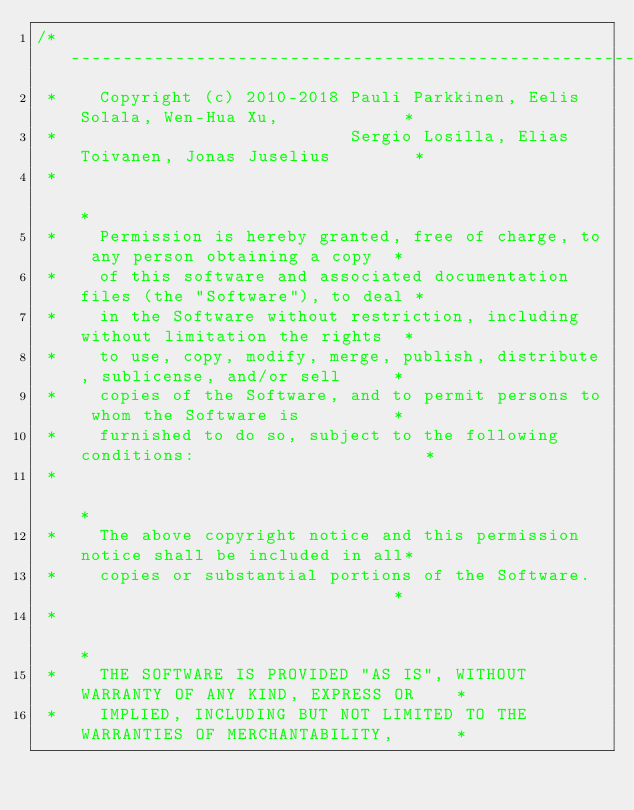Convert code to text. <code><loc_0><loc_0><loc_500><loc_500><_Cuda_>/*----------------------------------------------------------------------------------*
 *    Copyright (c) 2010-2018 Pauli Parkkinen, Eelis Solala, Wen-Hua Xu,            *
 *                            Sergio Losilla, Elias Toivanen, Jonas Juselius        *
 *                                                                                  *
 *    Permission is hereby granted, free of charge, to any person obtaining a copy  *
 *    of this software and associated documentation files (the "Software"), to deal *
 *    in the Software without restriction, including without limitation the rights  *
 *    to use, copy, modify, merge, publish, distribute, sublicense, and/or sell     *
 *    copies of the Software, and to permit persons to whom the Software is         *
 *    furnished to do so, subject to the following conditions:                      *
 *                                                                                  *
 *    The above copyright notice and this permission notice shall be included in all*
 *    copies or substantial portions of the Software.                               *
 *                                                                                  *
 *    THE SOFTWARE IS PROVIDED "AS IS", WITHOUT WARRANTY OF ANY KIND, EXPRESS OR    *
 *    IMPLIED, INCLUDING BUT NOT LIMITED TO THE WARRANTIES OF MERCHANTABILITY,      *</code> 